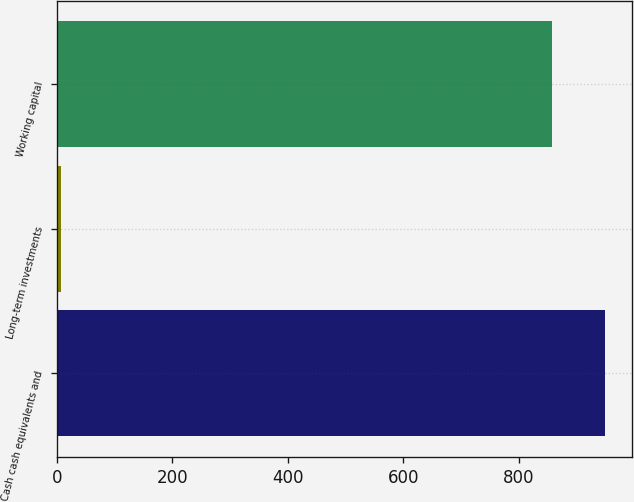<chart> <loc_0><loc_0><loc_500><loc_500><bar_chart><fcel>Cash cash equivalents and<fcel>Long-term investments<fcel>Working capital<nl><fcel>948.9<fcel>8<fcel>858<nl></chart> 